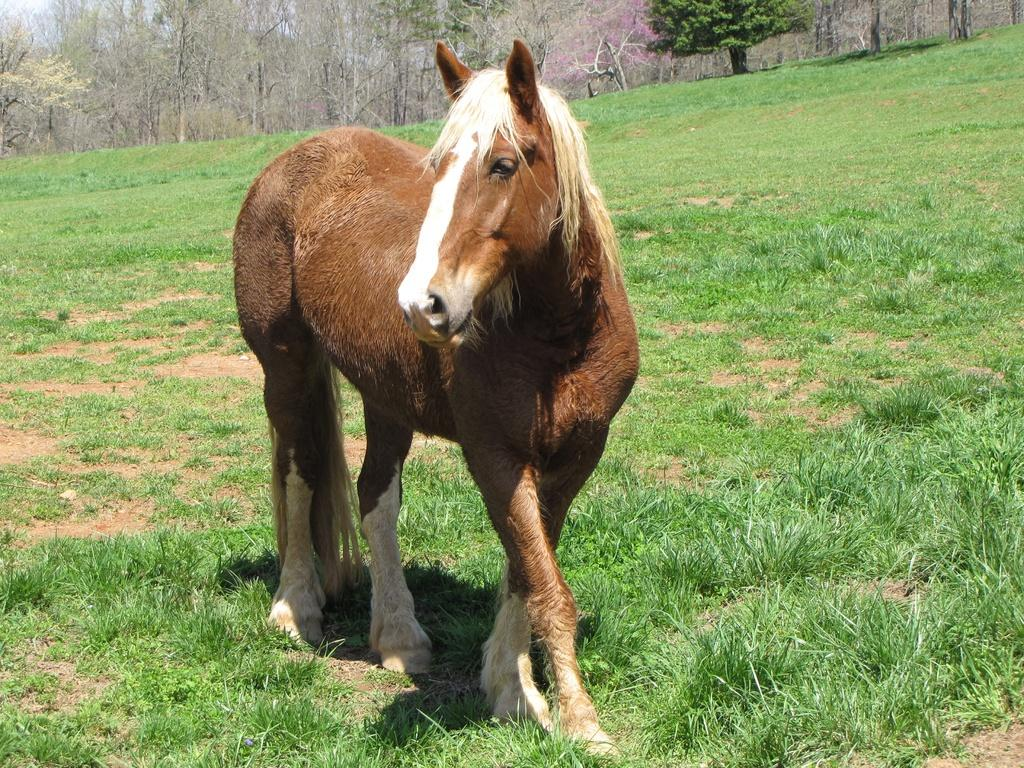What is the main subject in the middle of the image? There is a horse in the middle of the image. What type of terrain is visible at the bottom of the image? There is grassy land at the bottom of the image. What type of vegetation is present at the top of the image? There are trees at the top of the image. What type of behavior does the horse exhibit in response to the smoke in the image? There is no smoke present in the image, so the horse's behavior in response to it cannot be determined. 